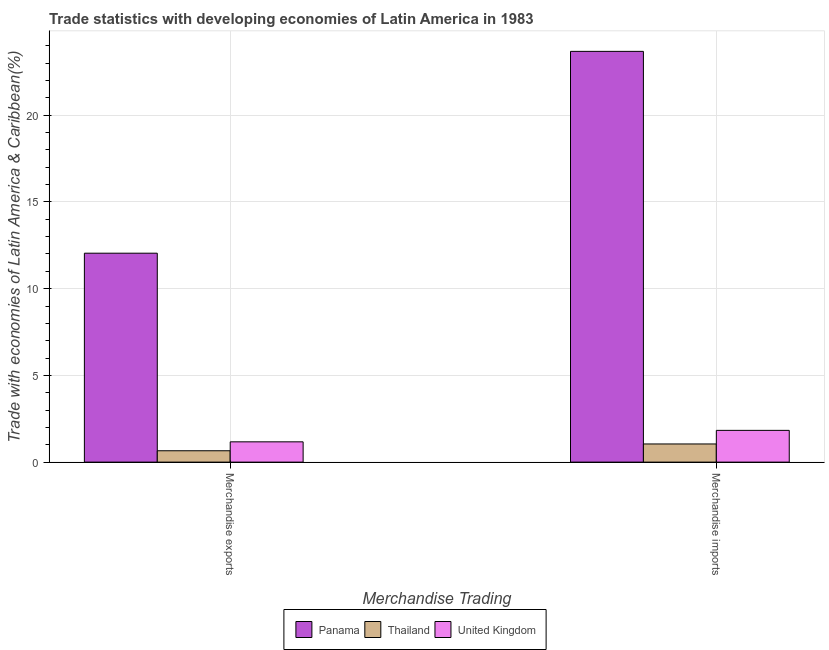How many different coloured bars are there?
Keep it short and to the point. 3. Are the number of bars per tick equal to the number of legend labels?
Your response must be concise. Yes. Are the number of bars on each tick of the X-axis equal?
Ensure brevity in your answer.  Yes. How many bars are there on the 2nd tick from the left?
Your answer should be very brief. 3. What is the label of the 2nd group of bars from the left?
Offer a terse response. Merchandise imports. What is the merchandise exports in United Kingdom?
Offer a terse response. 1.17. Across all countries, what is the maximum merchandise imports?
Give a very brief answer. 23.68. Across all countries, what is the minimum merchandise exports?
Provide a short and direct response. 0.66. In which country was the merchandise exports maximum?
Offer a terse response. Panama. In which country was the merchandise imports minimum?
Offer a very short reply. Thailand. What is the total merchandise exports in the graph?
Make the answer very short. 13.87. What is the difference between the merchandise exports in Thailand and that in Panama?
Your answer should be very brief. -11.39. What is the difference between the merchandise exports in Thailand and the merchandise imports in United Kingdom?
Your response must be concise. -1.18. What is the average merchandise exports per country?
Offer a very short reply. 4.62. What is the difference between the merchandise exports and merchandise imports in Thailand?
Your answer should be very brief. -0.39. What is the ratio of the merchandise exports in Thailand to that in United Kingdom?
Offer a very short reply. 0.56. Is the merchandise exports in Panama less than that in United Kingdom?
Your answer should be compact. No. What does the 1st bar from the left in Merchandise imports represents?
Ensure brevity in your answer.  Panama. What does the 3rd bar from the right in Merchandise exports represents?
Make the answer very short. Panama. How many countries are there in the graph?
Give a very brief answer. 3. Does the graph contain any zero values?
Provide a short and direct response. No. Does the graph contain grids?
Your response must be concise. Yes. How many legend labels are there?
Your answer should be very brief. 3. What is the title of the graph?
Provide a succinct answer. Trade statistics with developing economies of Latin America in 1983. What is the label or title of the X-axis?
Give a very brief answer. Merchandise Trading. What is the label or title of the Y-axis?
Provide a short and direct response. Trade with economies of Latin America & Caribbean(%). What is the Trade with economies of Latin America & Caribbean(%) of Panama in Merchandise exports?
Your response must be concise. 12.05. What is the Trade with economies of Latin America & Caribbean(%) of Thailand in Merchandise exports?
Your response must be concise. 0.66. What is the Trade with economies of Latin America & Caribbean(%) in United Kingdom in Merchandise exports?
Offer a very short reply. 1.17. What is the Trade with economies of Latin America & Caribbean(%) in Panama in Merchandise imports?
Your answer should be compact. 23.68. What is the Trade with economies of Latin America & Caribbean(%) of Thailand in Merchandise imports?
Ensure brevity in your answer.  1.05. What is the Trade with economies of Latin America & Caribbean(%) in United Kingdom in Merchandise imports?
Your response must be concise. 1.83. Across all Merchandise Trading, what is the maximum Trade with economies of Latin America & Caribbean(%) in Panama?
Make the answer very short. 23.68. Across all Merchandise Trading, what is the maximum Trade with economies of Latin America & Caribbean(%) of Thailand?
Your response must be concise. 1.05. Across all Merchandise Trading, what is the maximum Trade with economies of Latin America & Caribbean(%) of United Kingdom?
Your answer should be very brief. 1.83. Across all Merchandise Trading, what is the minimum Trade with economies of Latin America & Caribbean(%) of Panama?
Give a very brief answer. 12.05. Across all Merchandise Trading, what is the minimum Trade with economies of Latin America & Caribbean(%) in Thailand?
Your response must be concise. 0.66. Across all Merchandise Trading, what is the minimum Trade with economies of Latin America & Caribbean(%) of United Kingdom?
Ensure brevity in your answer.  1.17. What is the total Trade with economies of Latin America & Caribbean(%) of Panama in the graph?
Offer a terse response. 35.73. What is the total Trade with economies of Latin America & Caribbean(%) in Thailand in the graph?
Offer a very short reply. 1.7. What is the total Trade with economies of Latin America & Caribbean(%) in United Kingdom in the graph?
Give a very brief answer. 3. What is the difference between the Trade with economies of Latin America & Caribbean(%) of Panama in Merchandise exports and that in Merchandise imports?
Provide a short and direct response. -11.64. What is the difference between the Trade with economies of Latin America & Caribbean(%) of Thailand in Merchandise exports and that in Merchandise imports?
Give a very brief answer. -0.39. What is the difference between the Trade with economies of Latin America & Caribbean(%) in United Kingdom in Merchandise exports and that in Merchandise imports?
Your answer should be compact. -0.66. What is the difference between the Trade with economies of Latin America & Caribbean(%) in Panama in Merchandise exports and the Trade with economies of Latin America & Caribbean(%) in Thailand in Merchandise imports?
Keep it short and to the point. 11. What is the difference between the Trade with economies of Latin America & Caribbean(%) of Panama in Merchandise exports and the Trade with economies of Latin America & Caribbean(%) of United Kingdom in Merchandise imports?
Your answer should be very brief. 10.22. What is the difference between the Trade with economies of Latin America & Caribbean(%) of Thailand in Merchandise exports and the Trade with economies of Latin America & Caribbean(%) of United Kingdom in Merchandise imports?
Offer a very short reply. -1.18. What is the average Trade with economies of Latin America & Caribbean(%) in Panama per Merchandise Trading?
Keep it short and to the point. 17.86. What is the average Trade with economies of Latin America & Caribbean(%) in Thailand per Merchandise Trading?
Your answer should be compact. 0.85. What is the average Trade with economies of Latin America & Caribbean(%) of United Kingdom per Merchandise Trading?
Provide a short and direct response. 1.5. What is the difference between the Trade with economies of Latin America & Caribbean(%) of Panama and Trade with economies of Latin America & Caribbean(%) of Thailand in Merchandise exports?
Keep it short and to the point. 11.39. What is the difference between the Trade with economies of Latin America & Caribbean(%) of Panama and Trade with economies of Latin America & Caribbean(%) of United Kingdom in Merchandise exports?
Your answer should be very brief. 10.88. What is the difference between the Trade with economies of Latin America & Caribbean(%) in Thailand and Trade with economies of Latin America & Caribbean(%) in United Kingdom in Merchandise exports?
Give a very brief answer. -0.51. What is the difference between the Trade with economies of Latin America & Caribbean(%) of Panama and Trade with economies of Latin America & Caribbean(%) of Thailand in Merchandise imports?
Your answer should be compact. 22.64. What is the difference between the Trade with economies of Latin America & Caribbean(%) in Panama and Trade with economies of Latin America & Caribbean(%) in United Kingdom in Merchandise imports?
Provide a short and direct response. 21.85. What is the difference between the Trade with economies of Latin America & Caribbean(%) of Thailand and Trade with economies of Latin America & Caribbean(%) of United Kingdom in Merchandise imports?
Offer a terse response. -0.78. What is the ratio of the Trade with economies of Latin America & Caribbean(%) in Panama in Merchandise exports to that in Merchandise imports?
Ensure brevity in your answer.  0.51. What is the ratio of the Trade with economies of Latin America & Caribbean(%) of Thailand in Merchandise exports to that in Merchandise imports?
Keep it short and to the point. 0.63. What is the ratio of the Trade with economies of Latin America & Caribbean(%) of United Kingdom in Merchandise exports to that in Merchandise imports?
Make the answer very short. 0.64. What is the difference between the highest and the second highest Trade with economies of Latin America & Caribbean(%) in Panama?
Your answer should be very brief. 11.64. What is the difference between the highest and the second highest Trade with economies of Latin America & Caribbean(%) of Thailand?
Offer a terse response. 0.39. What is the difference between the highest and the second highest Trade with economies of Latin America & Caribbean(%) of United Kingdom?
Provide a succinct answer. 0.66. What is the difference between the highest and the lowest Trade with economies of Latin America & Caribbean(%) of Panama?
Make the answer very short. 11.64. What is the difference between the highest and the lowest Trade with economies of Latin America & Caribbean(%) of Thailand?
Offer a terse response. 0.39. What is the difference between the highest and the lowest Trade with economies of Latin America & Caribbean(%) of United Kingdom?
Ensure brevity in your answer.  0.66. 